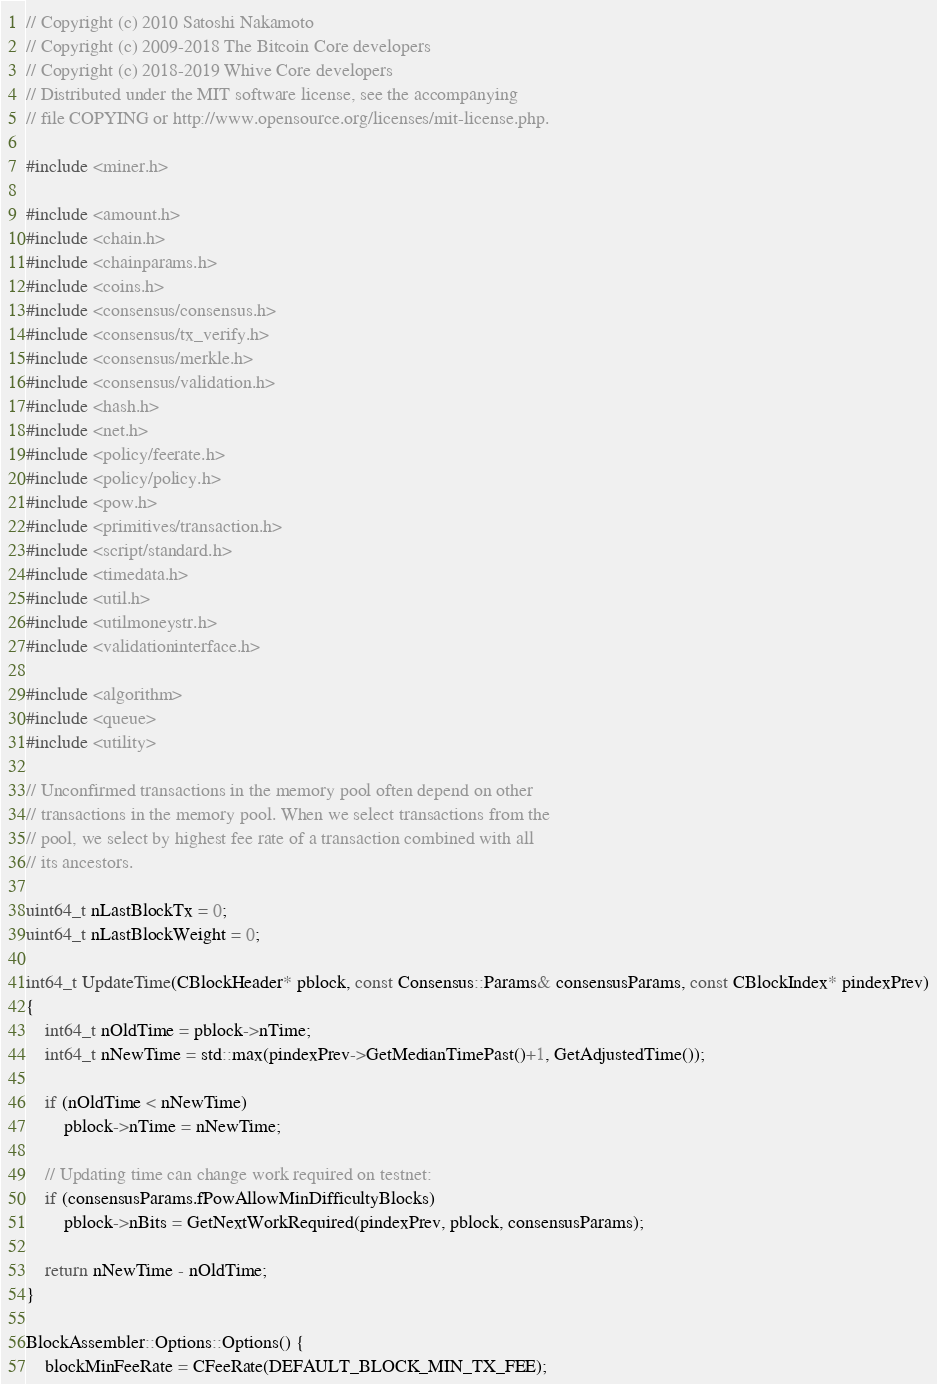Convert code to text. <code><loc_0><loc_0><loc_500><loc_500><_C++_>// Copyright (c) 2010 Satoshi Nakamoto
// Copyright (c) 2009-2018 The Bitcoin Core developers
// Copyright (c) 2018-2019 Whive Core developers
// Distributed under the MIT software license, see the accompanying
// file COPYING or http://www.opensource.org/licenses/mit-license.php.

#include <miner.h>

#include <amount.h>
#include <chain.h>
#include <chainparams.h>
#include <coins.h>
#include <consensus/consensus.h>
#include <consensus/tx_verify.h>
#include <consensus/merkle.h>
#include <consensus/validation.h>
#include <hash.h>
#include <net.h>
#include <policy/feerate.h>
#include <policy/policy.h>
#include <pow.h>
#include <primitives/transaction.h>
#include <script/standard.h>
#include <timedata.h>
#include <util.h>
#include <utilmoneystr.h>
#include <validationinterface.h>

#include <algorithm>
#include <queue>
#include <utility>

// Unconfirmed transactions in the memory pool often depend on other
// transactions in the memory pool. When we select transactions from the
// pool, we select by highest fee rate of a transaction combined with all
// its ancestors.

uint64_t nLastBlockTx = 0;
uint64_t nLastBlockWeight = 0;

int64_t UpdateTime(CBlockHeader* pblock, const Consensus::Params& consensusParams, const CBlockIndex* pindexPrev)
{
    int64_t nOldTime = pblock->nTime;
    int64_t nNewTime = std::max(pindexPrev->GetMedianTimePast()+1, GetAdjustedTime());

    if (nOldTime < nNewTime)
        pblock->nTime = nNewTime;

    // Updating time can change work required on testnet:
    if (consensusParams.fPowAllowMinDifficultyBlocks)
        pblock->nBits = GetNextWorkRequired(pindexPrev, pblock, consensusParams);

    return nNewTime - nOldTime;
}

BlockAssembler::Options::Options() {
    blockMinFeeRate = CFeeRate(DEFAULT_BLOCK_MIN_TX_FEE);</code> 